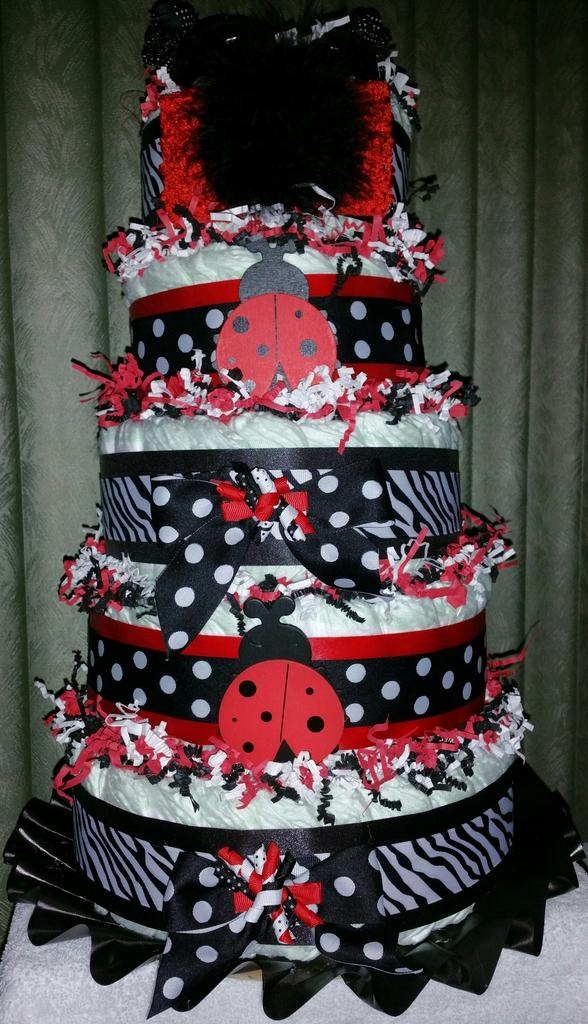What type of dessert is featured in the image? There is a colourful cake in the image. What can be seen in the background of the image? There is a curtain in the background of the image. What is placed under the cake in the image? There is a white cloth under the cake in the image. How many cats are wearing vests in the image? There are no cats or vests present in the image. 